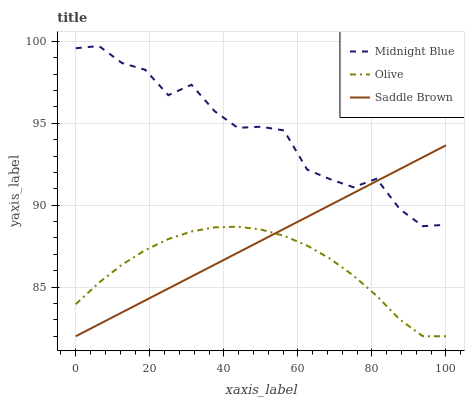Does Olive have the minimum area under the curve?
Answer yes or no. Yes. Does Midnight Blue have the maximum area under the curve?
Answer yes or no. Yes. Does Saddle Brown have the minimum area under the curve?
Answer yes or no. No. Does Saddle Brown have the maximum area under the curve?
Answer yes or no. No. Is Saddle Brown the smoothest?
Answer yes or no. Yes. Is Midnight Blue the roughest?
Answer yes or no. Yes. Is Midnight Blue the smoothest?
Answer yes or no. No. Is Saddle Brown the roughest?
Answer yes or no. No. Does Olive have the lowest value?
Answer yes or no. Yes. Does Midnight Blue have the lowest value?
Answer yes or no. No. Does Midnight Blue have the highest value?
Answer yes or no. Yes. Does Saddle Brown have the highest value?
Answer yes or no. No. Is Olive less than Midnight Blue?
Answer yes or no. Yes. Is Midnight Blue greater than Olive?
Answer yes or no. Yes. Does Saddle Brown intersect Olive?
Answer yes or no. Yes. Is Saddle Brown less than Olive?
Answer yes or no. No. Is Saddle Brown greater than Olive?
Answer yes or no. No. Does Olive intersect Midnight Blue?
Answer yes or no. No. 